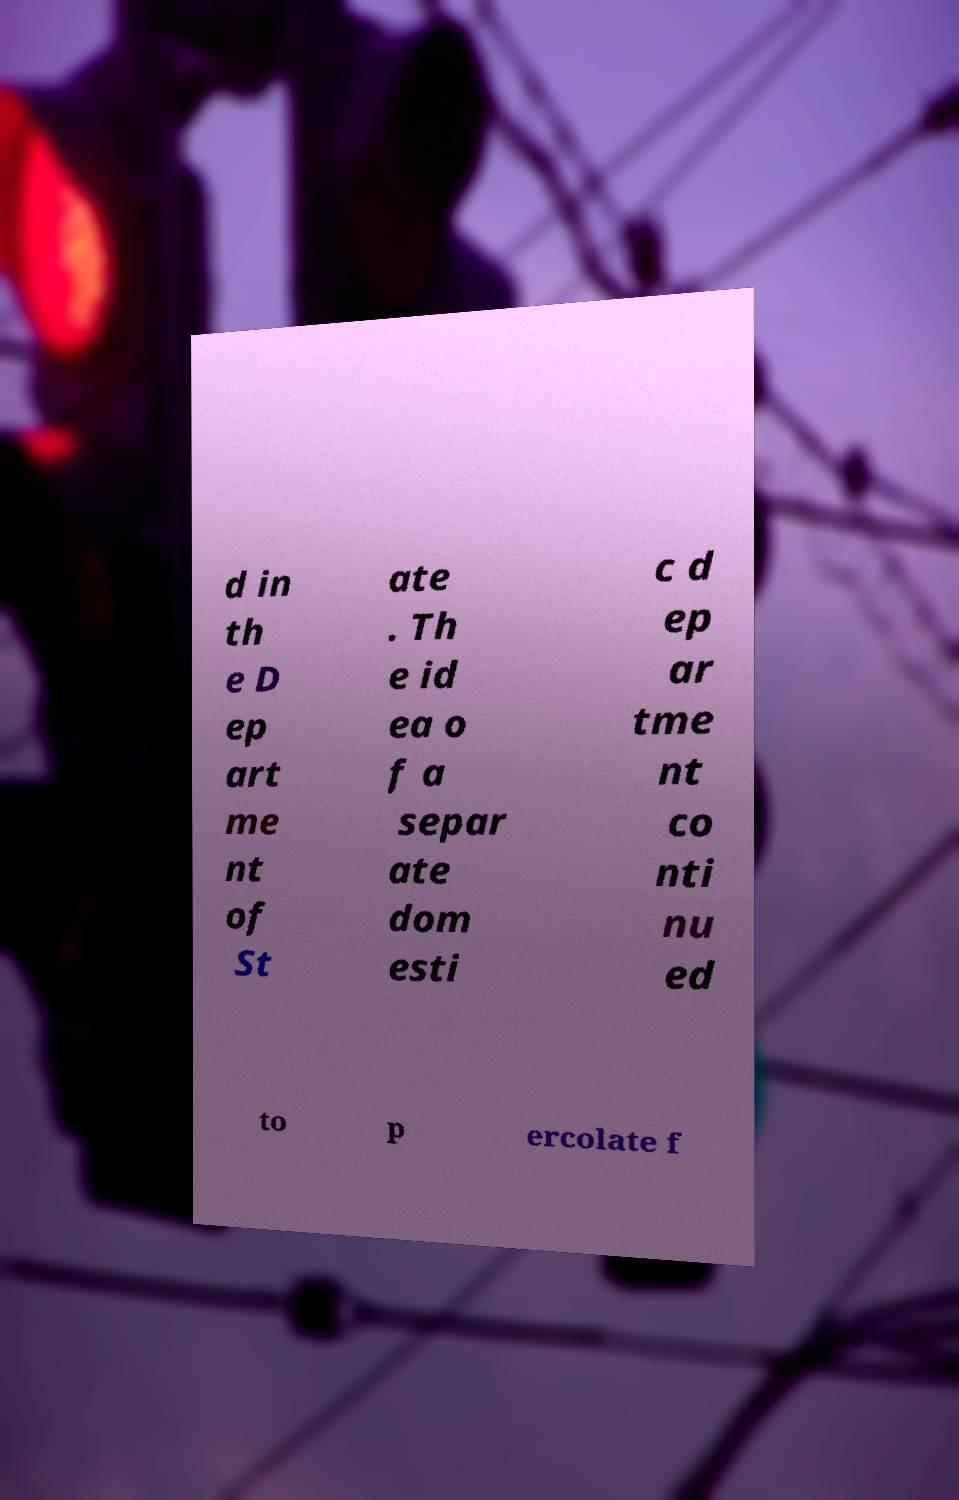Can you accurately transcribe the text from the provided image for me? d in th e D ep art me nt of St ate . Th e id ea o f a separ ate dom esti c d ep ar tme nt co nti nu ed to p ercolate f 